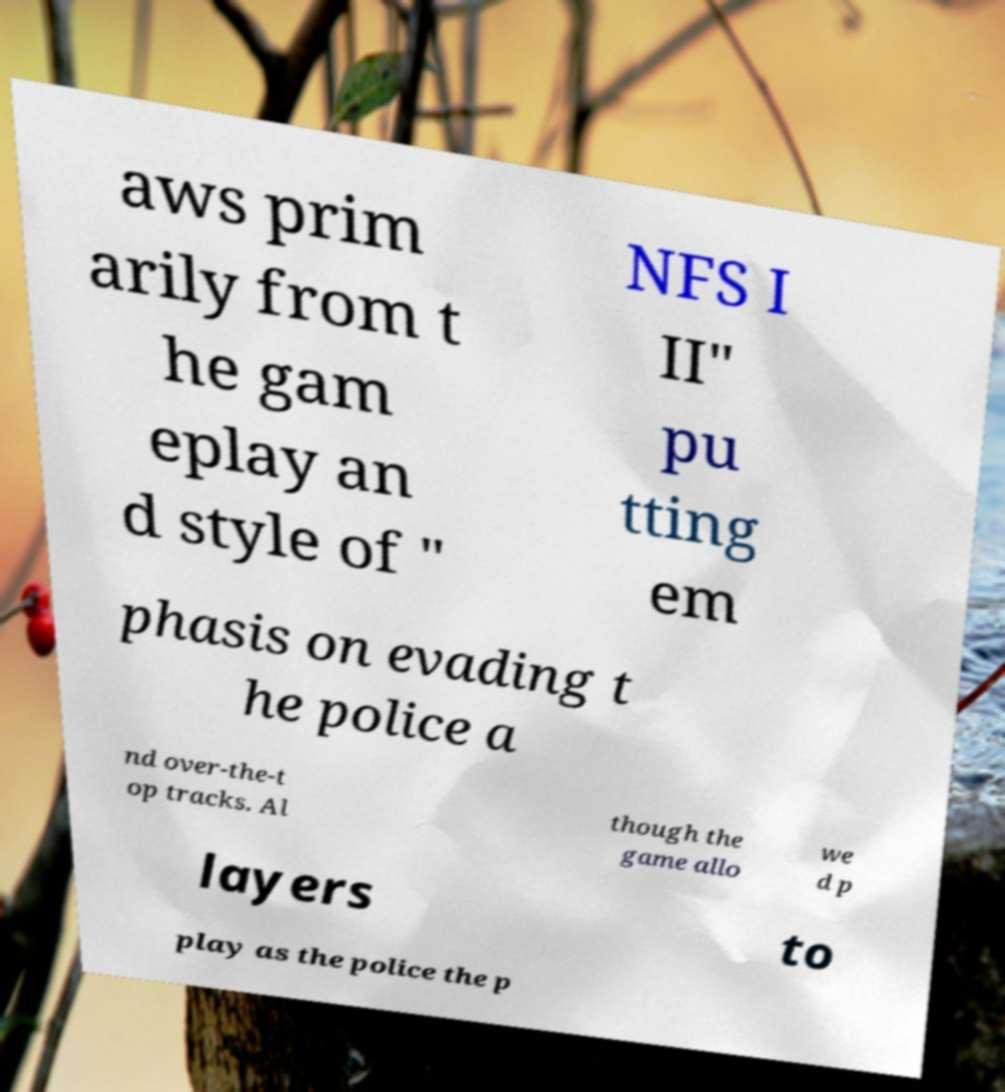There's text embedded in this image that I need extracted. Can you transcribe it verbatim? aws prim arily from t he gam eplay an d style of " NFS I II" pu tting em phasis on evading t he police a nd over-the-t op tracks. Al though the game allo we d p layers to play as the police the p 